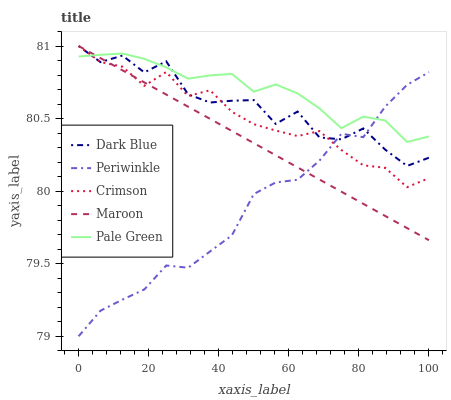Does Periwinkle have the minimum area under the curve?
Answer yes or no. Yes. Does Pale Green have the maximum area under the curve?
Answer yes or no. Yes. Does Dark Blue have the minimum area under the curve?
Answer yes or no. No. Does Dark Blue have the maximum area under the curve?
Answer yes or no. No. Is Maroon the smoothest?
Answer yes or no. Yes. Is Dark Blue the roughest?
Answer yes or no. Yes. Is Pale Green the smoothest?
Answer yes or no. No. Is Pale Green the roughest?
Answer yes or no. No. Does Periwinkle have the lowest value?
Answer yes or no. Yes. Does Dark Blue have the lowest value?
Answer yes or no. No. Does Maroon have the highest value?
Answer yes or no. Yes. Does Pale Green have the highest value?
Answer yes or no. No. Does Pale Green intersect Periwinkle?
Answer yes or no. Yes. Is Pale Green less than Periwinkle?
Answer yes or no. No. Is Pale Green greater than Periwinkle?
Answer yes or no. No. 